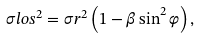Convert formula to latex. <formula><loc_0><loc_0><loc_500><loc_500>\sigma l o s ^ { 2 } = \sigma r ^ { 2 } \left ( 1 - \beta \sin ^ { 2 } \varphi \right ) ,</formula> 